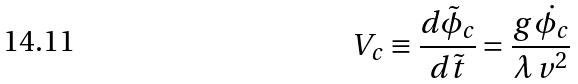Convert formula to latex. <formula><loc_0><loc_0><loc_500><loc_500>V _ { c } \equiv \frac { d \tilde { \phi } _ { c } } { d \tilde { t } } = \frac { g \, \dot { \phi _ { c } } } { \lambda \, v ^ { 2 } }</formula> 